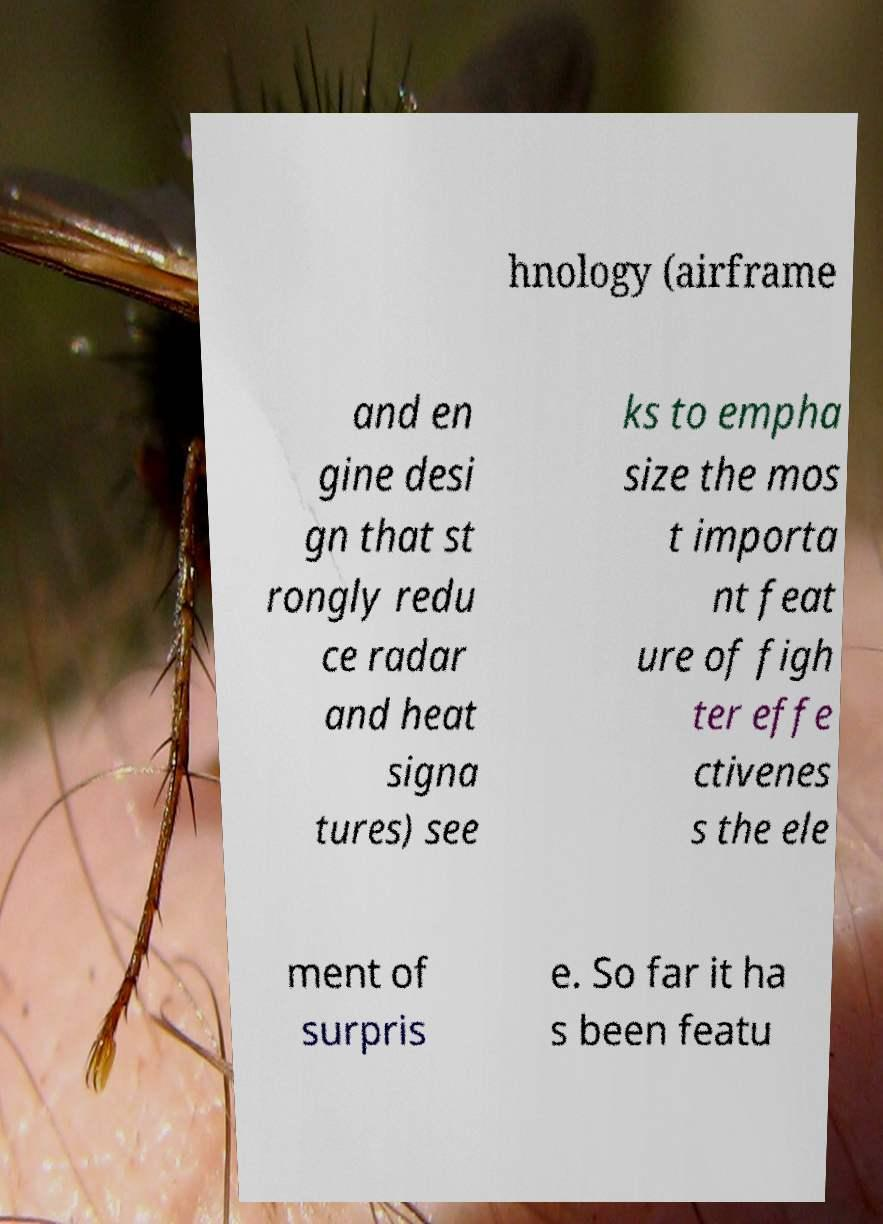What messages or text are displayed in this image? I need them in a readable, typed format. hnology (airframe and en gine desi gn that st rongly redu ce radar and heat signa tures) see ks to empha size the mos t importa nt feat ure of figh ter effe ctivenes s the ele ment of surpris e. So far it ha s been featu 